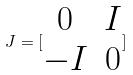Convert formula to latex. <formula><loc_0><loc_0><loc_500><loc_500>J = [ \begin{matrix} 0 & I \\ - I & 0 \end{matrix} ]</formula> 